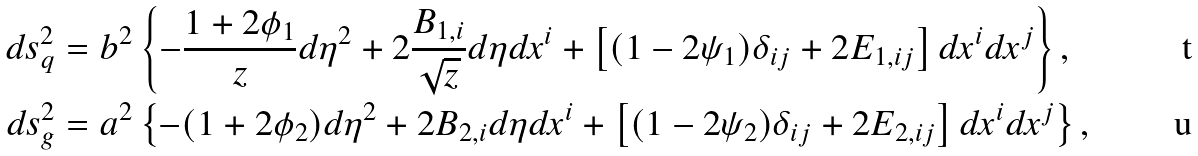Convert formula to latex. <formula><loc_0><loc_0><loc_500><loc_500>d s _ { q } ^ { 2 } & = b ^ { 2 } \left \{ - \frac { 1 + 2 \phi _ { 1 } } { z } d \eta ^ { 2 } + 2 \frac { B _ { 1 , i } } { \sqrt { z } } d \eta d x ^ { i } + \left [ ( 1 - 2 \psi _ { 1 } ) \delta _ { i j } + 2 E _ { 1 , i j } \right ] d x ^ { i } d x ^ { j } \right \} , \\ d s _ { g } ^ { 2 } & = a ^ { 2 } \left \{ - ( 1 + 2 \phi _ { 2 } ) d \eta ^ { 2 } + 2 B _ { 2 , i } d \eta d x ^ { i } + \left [ ( 1 - 2 \psi _ { 2 } ) \delta _ { i j } + 2 E _ { 2 , i j } \right ] d x ^ { i } d x ^ { j } \right \} ,</formula> 